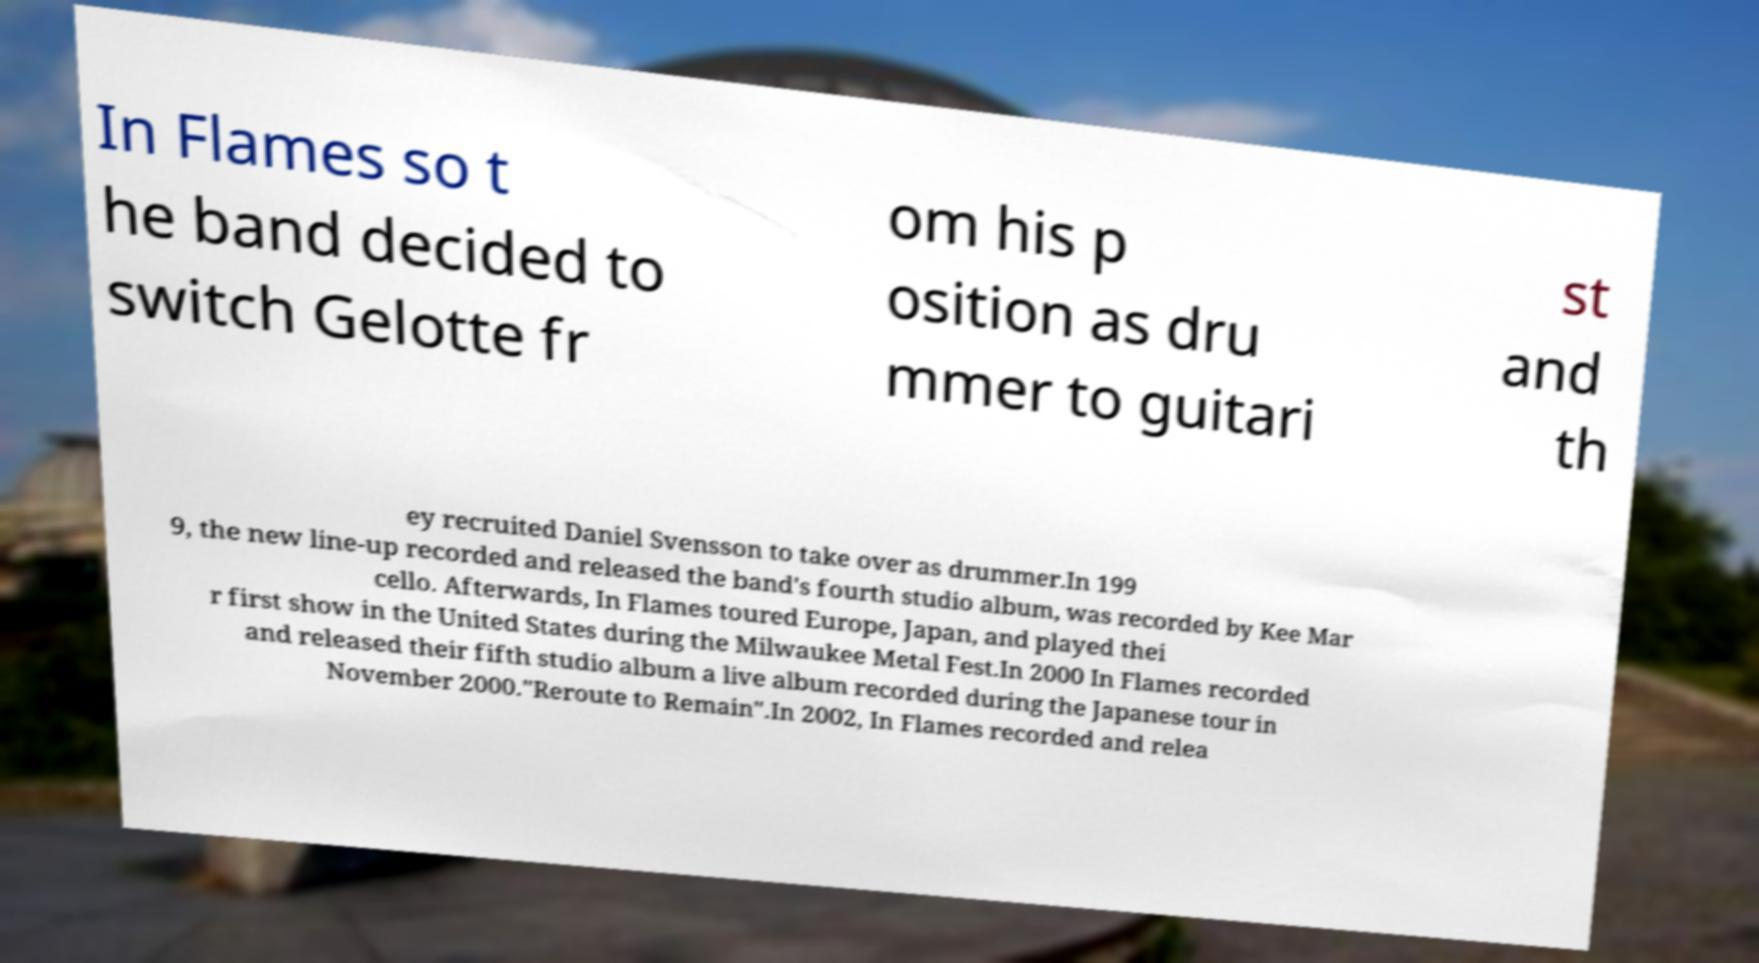Could you assist in decoding the text presented in this image and type it out clearly? In Flames so t he band decided to switch Gelotte fr om his p osition as dru mmer to guitari st and th ey recruited Daniel Svensson to take over as drummer.In 199 9, the new line-up recorded and released the band's fourth studio album, was recorded by Kee Mar cello. Afterwards, In Flames toured Europe, Japan, and played thei r first show in the United States during the Milwaukee Metal Fest.In 2000 In Flames recorded and released their fifth studio album a live album recorded during the Japanese tour in November 2000."Reroute to Remain".In 2002, In Flames recorded and relea 